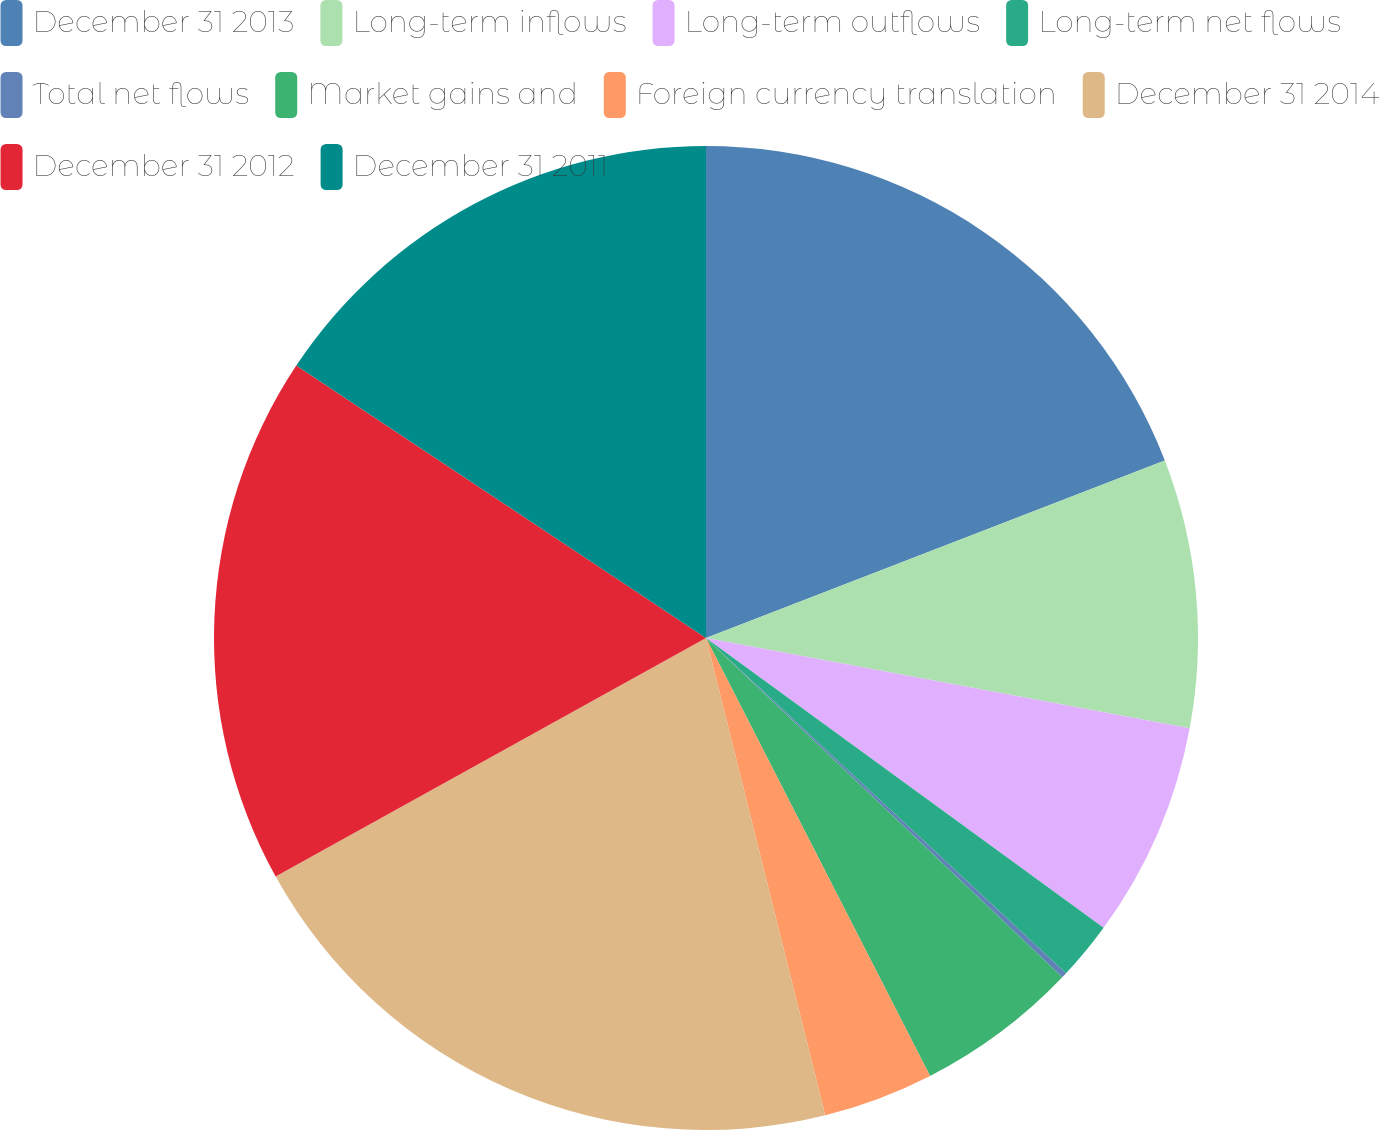Convert chart. <chart><loc_0><loc_0><loc_500><loc_500><pie_chart><fcel>December 31 2013<fcel>Long-term inflows<fcel>Long-term outflows<fcel>Long-term net flows<fcel>Total net flows<fcel>Market gains and<fcel>Foreign currency translation<fcel>December 31 2014<fcel>December 31 2012<fcel>December 31 2011<nl><fcel>19.12%<fcel>8.81%<fcel>7.09%<fcel>1.91%<fcel>0.18%<fcel>5.36%<fcel>3.63%<fcel>20.84%<fcel>17.39%<fcel>15.66%<nl></chart> 